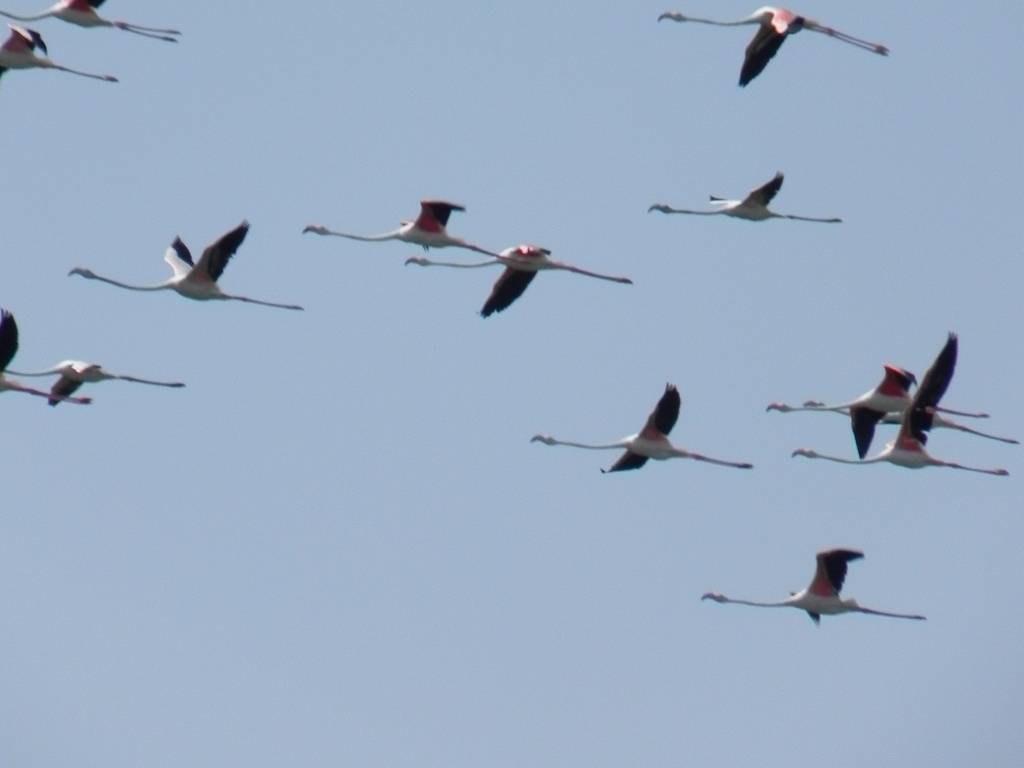Can you explain the significance of bird migration and how it might relate to this image? Bird migration is a natural phenomenon where birds travel from one habitat to another to exploit seasonal resources such as food and nesting locations. This image likely captures a moment of such a journey. Flamingos, the birds shown here, often migrate over long distances to find suitable wetlands during different seasons for feeding and breeding. 